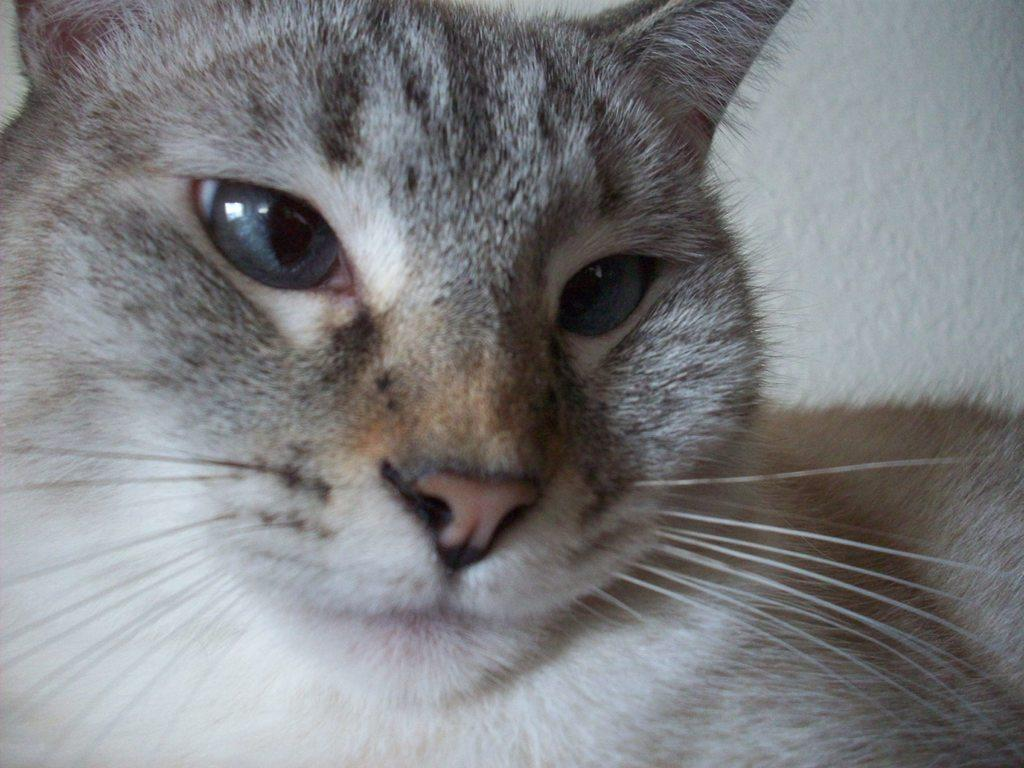What is the main subject of the image? The main subject of the image is a cat. What is the cat doing in the image? The cat is looking at the camera. What color is the background of the image? The background of the image is white in color. What month is it in the image? The image does not provide any information about the month, as it is a close-up view of a cat. Is there a goose present in the image? No, there is no goose present in the image; it features a cat. 